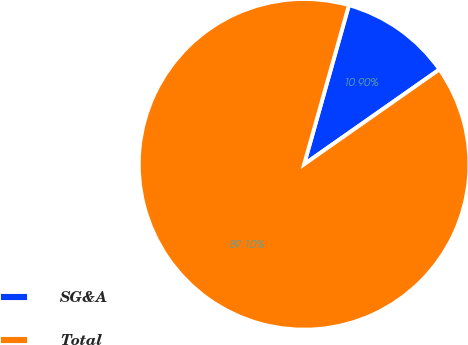Convert chart. <chart><loc_0><loc_0><loc_500><loc_500><pie_chart><fcel>SG&A<fcel>Total<nl><fcel>10.9%<fcel>89.1%<nl></chart> 